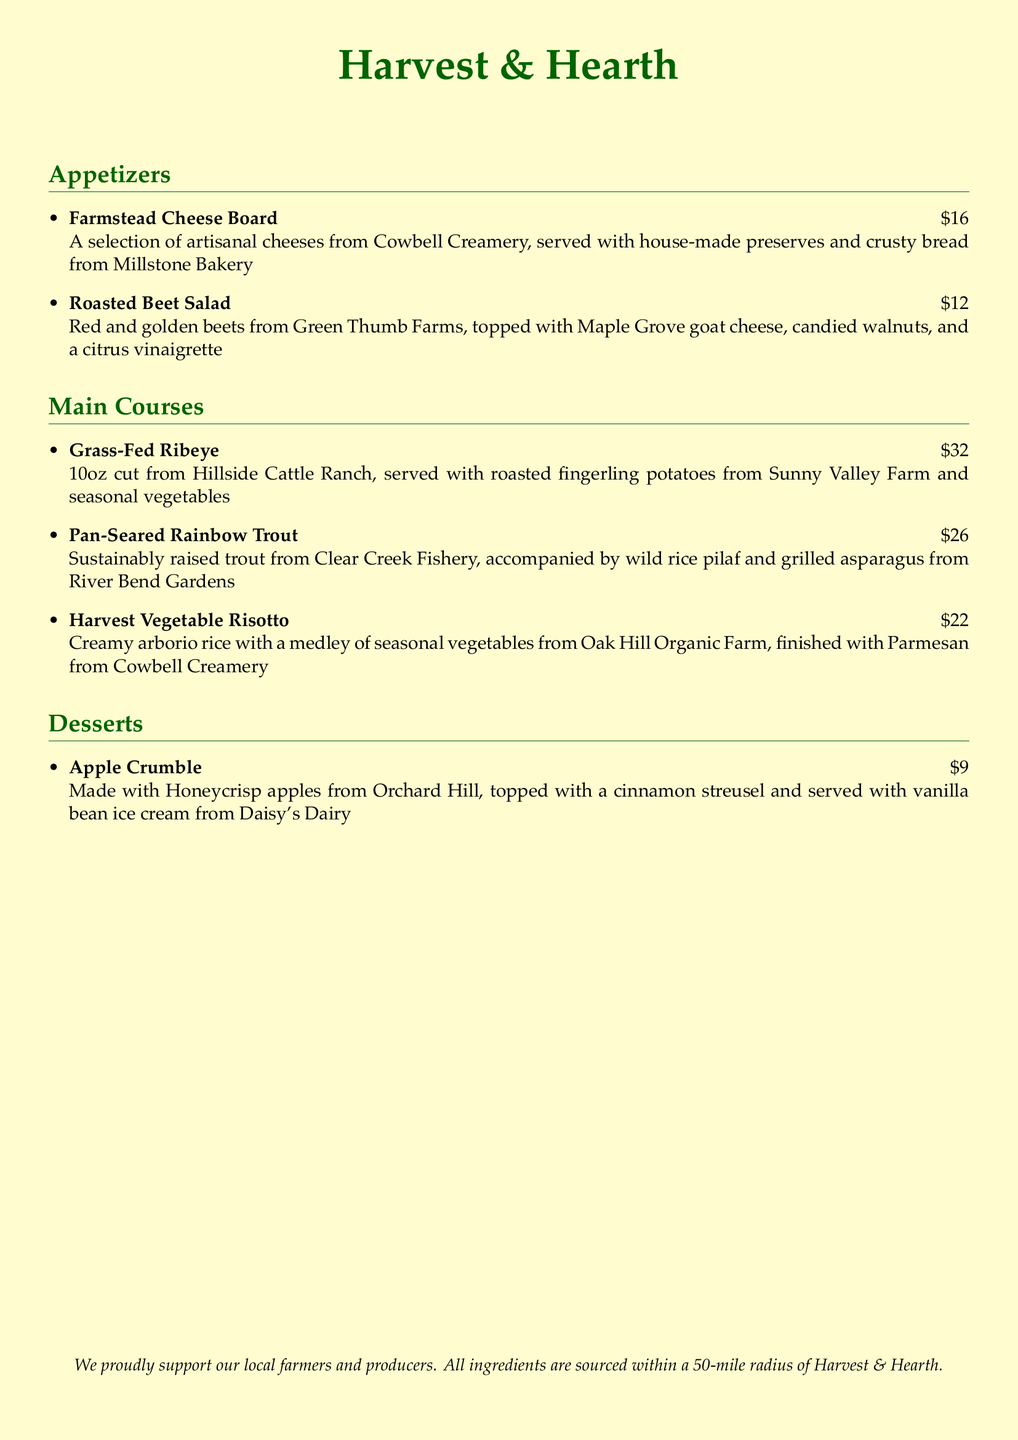What is the name of the restaurant? The name of the restaurant appears prominently at the top of the menu.
Answer: Harvest & Hearth How much does the Roasted Beet Salad cost? The price of the Roasted Beet Salad is indicated next to its name in the appetizers section.
Answer: $12 Which farm supplies the goat cheese for the salad? The farm providing the goat cheese is mentioned in the description of the Roasted Beet Salad.
Answer: Maple Grove What type of fish is served as a main course? The type of fish can be found in the main courses section detailing the Pan-Seared Rainbow Trout.
Answer: Rainbow Trout How many ounces is the Grass-Fed Ribeye? The weight of the Grass-Fed Ribeye is specified in the main course description.
Answer: 10oz What dessert features Honeycrisp apples? The dessert made with Honeycrisp apples is given in the desserts section.
Answer: Apple Crumble Which bakery supplies bread for the cheese board? The bakery providing bread is included in the description of the Farmstead Cheese Board.
Answer: Millstone Bakery What is the primary ingredient in the Harvest Vegetable Risotto? The main ingredient in the Harvest Vegetable Risotto is highlighted in its description in the main courses section.
Answer: Arborio rice From what radius are ingredients sourced? The sourcing information is found at the bottom of the menu, specifying the distance.
Answer: 50-mile radius 